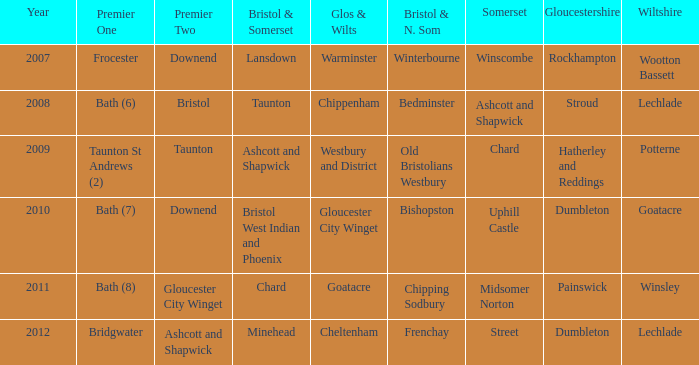What is the newest year when glos & wilts is referred to as warminster? 2007.0. 